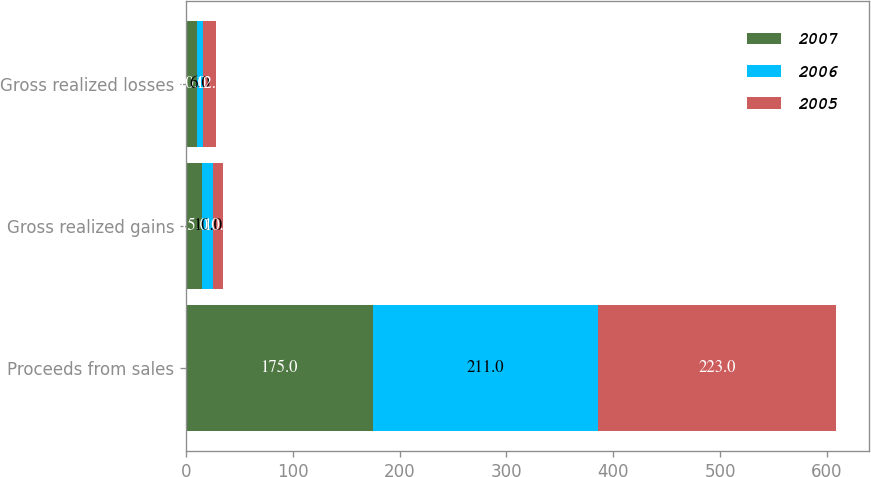<chart> <loc_0><loc_0><loc_500><loc_500><stacked_bar_chart><ecel><fcel>Proceeds from sales<fcel>Gross realized gains<fcel>Gross realized losses<nl><fcel>2007<fcel>175<fcel>15<fcel>10<nl><fcel>2006<fcel>211<fcel>10<fcel>6<nl><fcel>2005<fcel>223<fcel>10<fcel>12<nl></chart> 